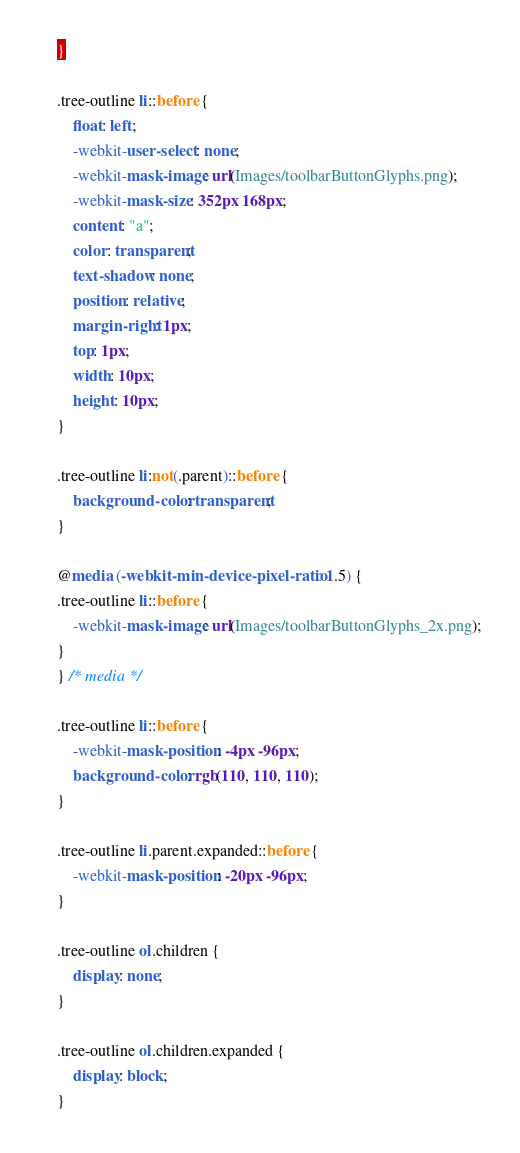Convert code to text. <code><loc_0><loc_0><loc_500><loc_500><_CSS_>}

.tree-outline li::before {
    float: left;
    -webkit-user-select: none;
    -webkit-mask-image: url(Images/toolbarButtonGlyphs.png);
    -webkit-mask-size: 352px 168px;
    content: "a";
    color: transparent;
    text-shadow: none;
    position: relative;
    margin-right: 1px;
    top: 1px;
    width: 10px;
    height: 10px;
}

.tree-outline li:not(.parent)::before {
    background-color: transparent;
}

@media (-webkit-min-device-pixel-ratio: 1.5) {
.tree-outline li::before {
    -webkit-mask-image: url(Images/toolbarButtonGlyphs_2x.png);
}
} /* media */

.tree-outline li::before {
    -webkit-mask-position: -4px -96px;
    background-color: rgb(110, 110, 110);
}

.tree-outline li.parent.expanded::before {
    -webkit-mask-position: -20px -96px;
}

.tree-outline ol.children {
    display: none;
}

.tree-outline ol.children.expanded {
    display: block;
}
</code> 